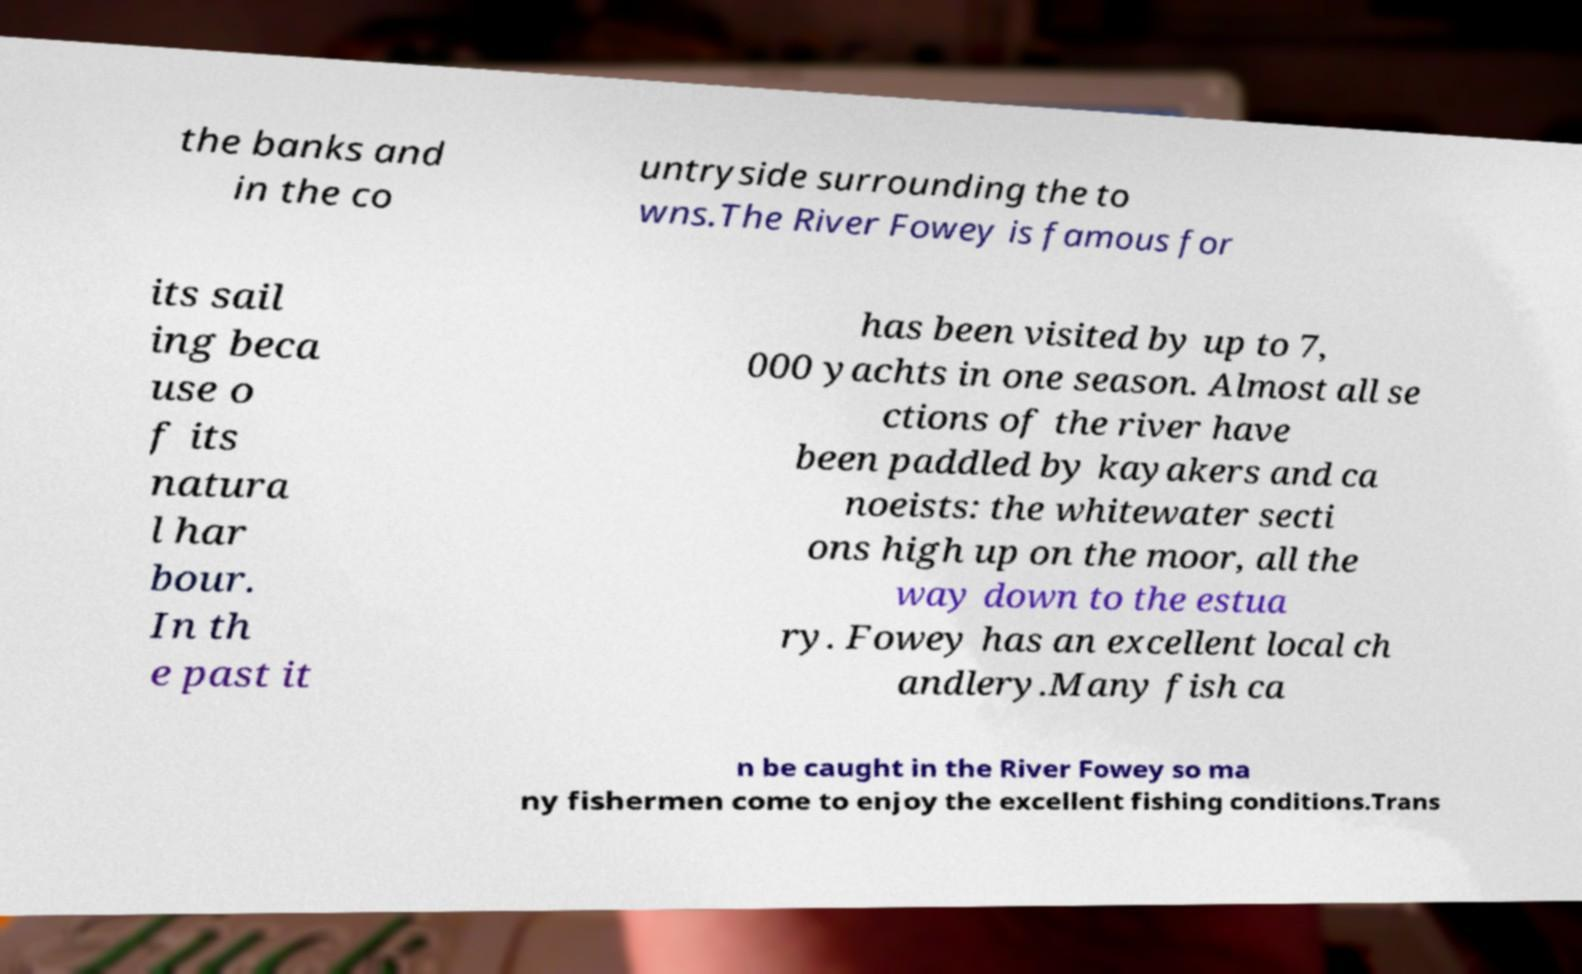For documentation purposes, I need the text within this image transcribed. Could you provide that? the banks and in the co untryside surrounding the to wns.The River Fowey is famous for its sail ing beca use o f its natura l har bour. In th e past it has been visited by up to 7, 000 yachts in one season. Almost all se ctions of the river have been paddled by kayakers and ca noeists: the whitewater secti ons high up on the moor, all the way down to the estua ry. Fowey has an excellent local ch andlery.Many fish ca n be caught in the River Fowey so ma ny fishermen come to enjoy the excellent fishing conditions.Trans 